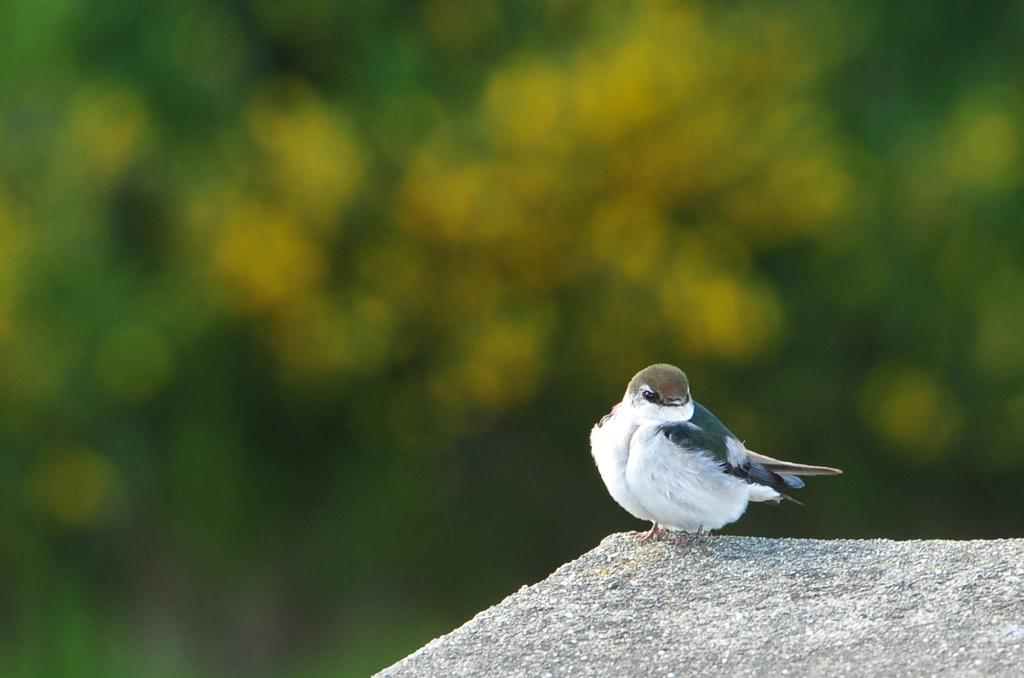What animal can be seen in the image? There is a bird in the image. What is the bird standing on? The bird is standing on a stone. On which side of the image is the bird located? The bird is on the right side of the image. What colors are present in the background of the image? There is green and yellow color in the background of the image. What song is the bird singing in the image? The image does not provide any information about the bird singing a song. 